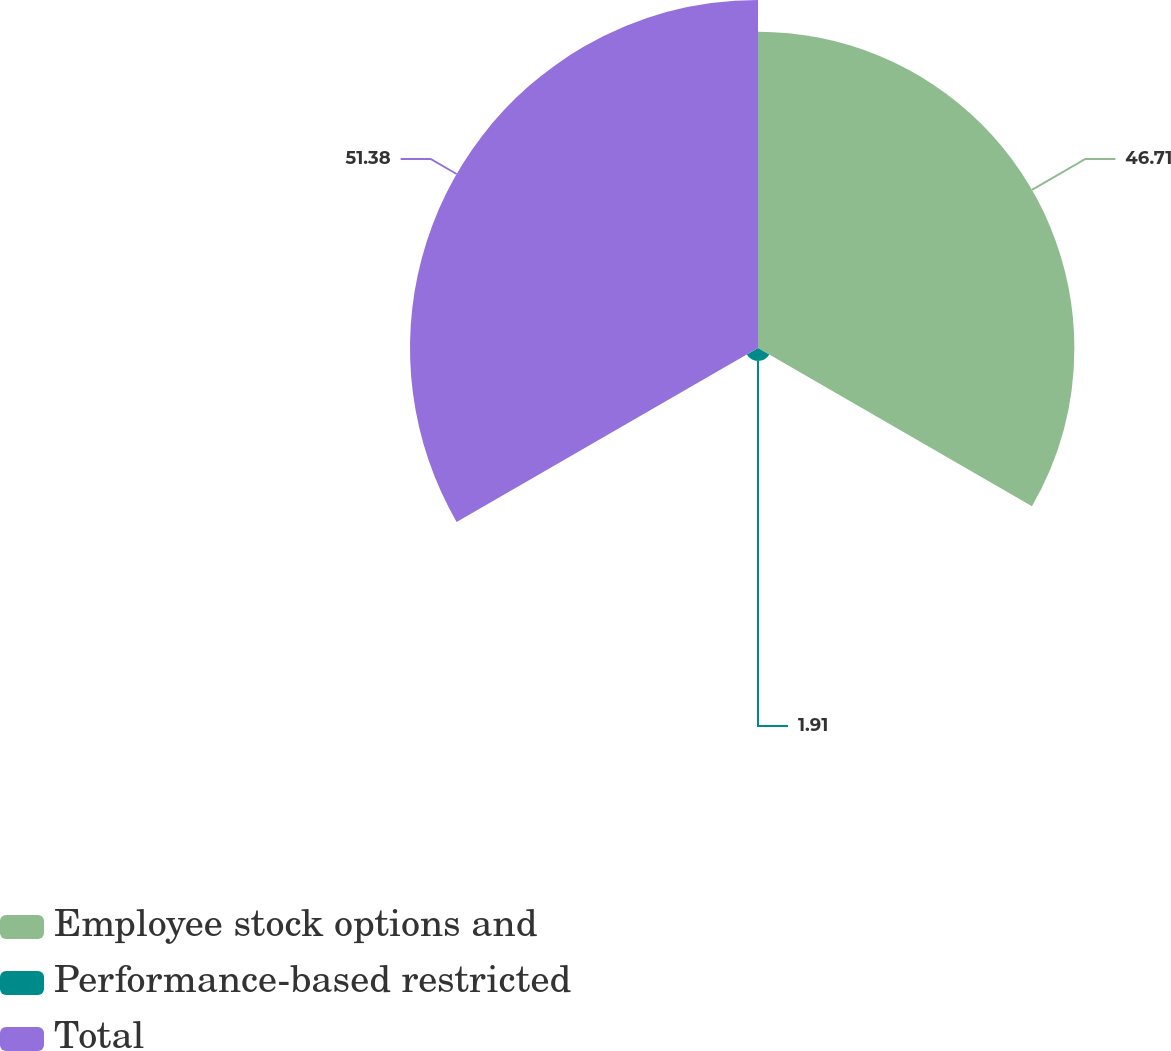Convert chart. <chart><loc_0><loc_0><loc_500><loc_500><pie_chart><fcel>Employee stock options and<fcel>Performance-based restricted<fcel>Total<nl><fcel>46.71%<fcel>1.91%<fcel>51.38%<nl></chart> 